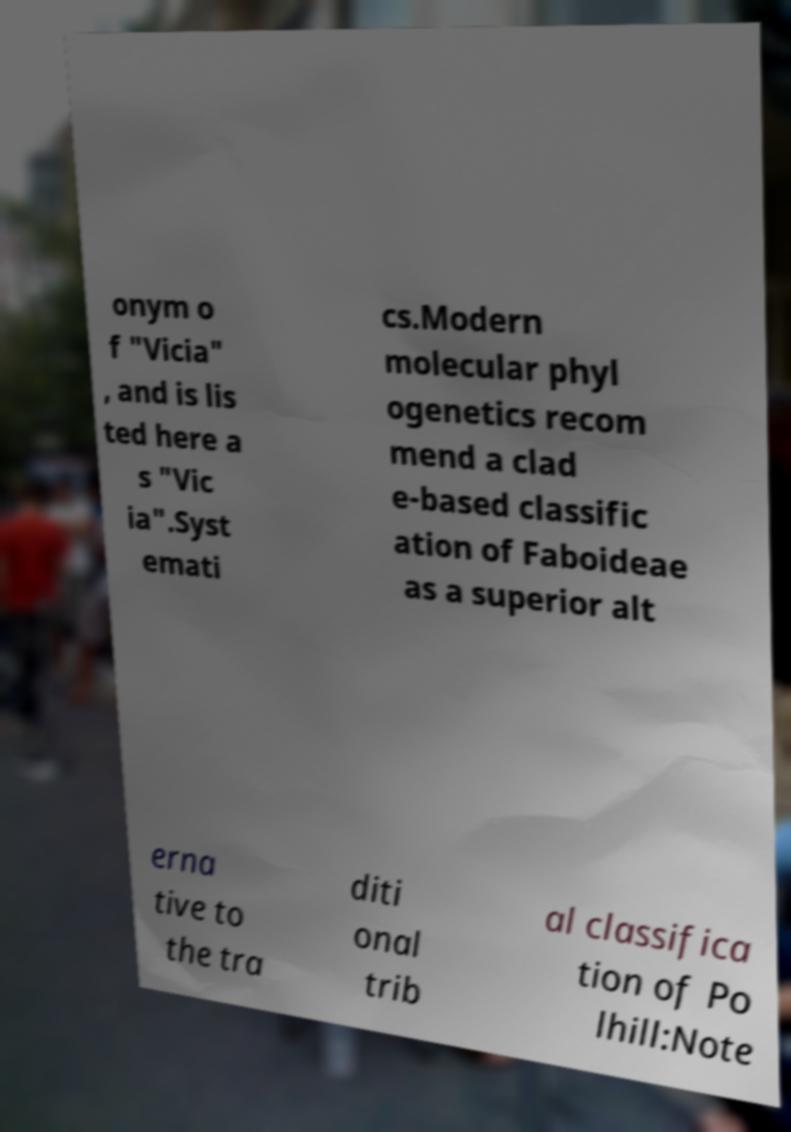Could you assist in decoding the text presented in this image and type it out clearly? onym o f "Vicia" , and is lis ted here a s "Vic ia".Syst emati cs.Modern molecular phyl ogenetics recom mend a clad e-based classific ation of Faboideae as a superior alt erna tive to the tra diti onal trib al classifica tion of Po lhill:Note 